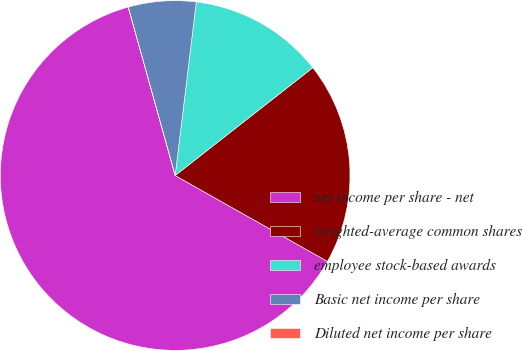Convert chart. <chart><loc_0><loc_0><loc_500><loc_500><pie_chart><fcel>net income per share - net<fcel>weighted-average common shares<fcel>employee stock-based awards<fcel>Basic net income per share<fcel>Diluted net income per share<nl><fcel>62.5%<fcel>18.75%<fcel>12.5%<fcel>6.25%<fcel>0.0%<nl></chart> 